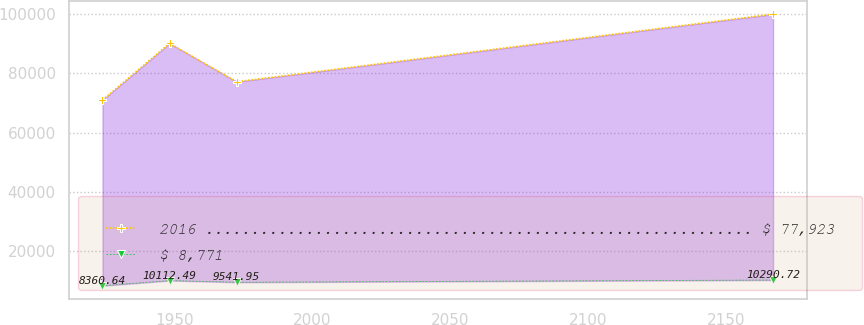Convert chart. <chart><loc_0><loc_0><loc_500><loc_500><line_chart><ecel><fcel>2016 ............................................................ $ 77,923<fcel>$ 8,771<nl><fcel>1923.97<fcel>71000.9<fcel>8360.64<nl><fcel>1948.29<fcel>90113.7<fcel>10112.5<nl><fcel>1972.61<fcel>77166.9<fcel>9541.95<nl><fcel>2167.12<fcel>99959.8<fcel>10290.7<nl></chart> 